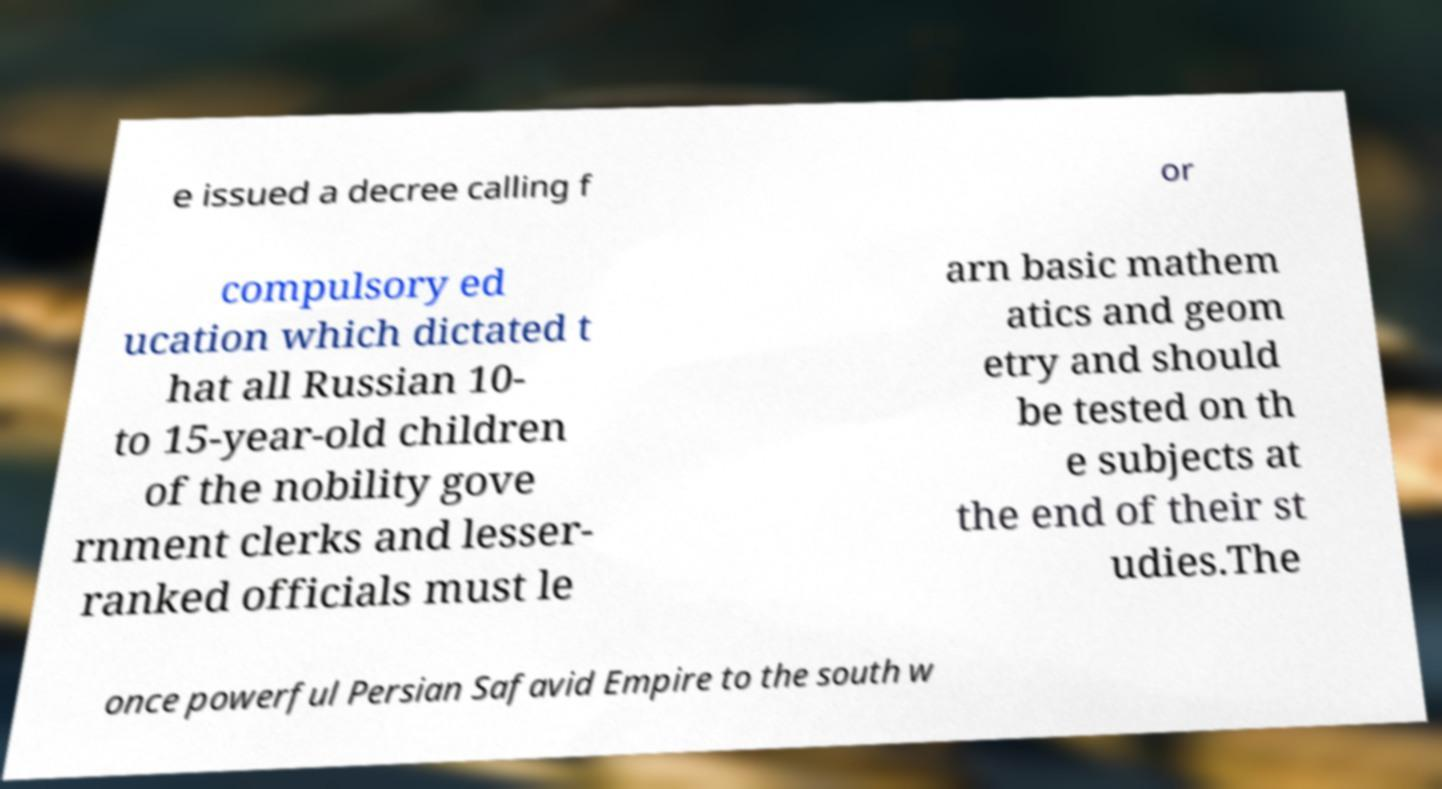I need the written content from this picture converted into text. Can you do that? e issued a decree calling f or compulsory ed ucation which dictated t hat all Russian 10- to 15-year-old children of the nobility gove rnment clerks and lesser- ranked officials must le arn basic mathem atics and geom etry and should be tested on th e subjects at the end of their st udies.The once powerful Persian Safavid Empire to the south w 